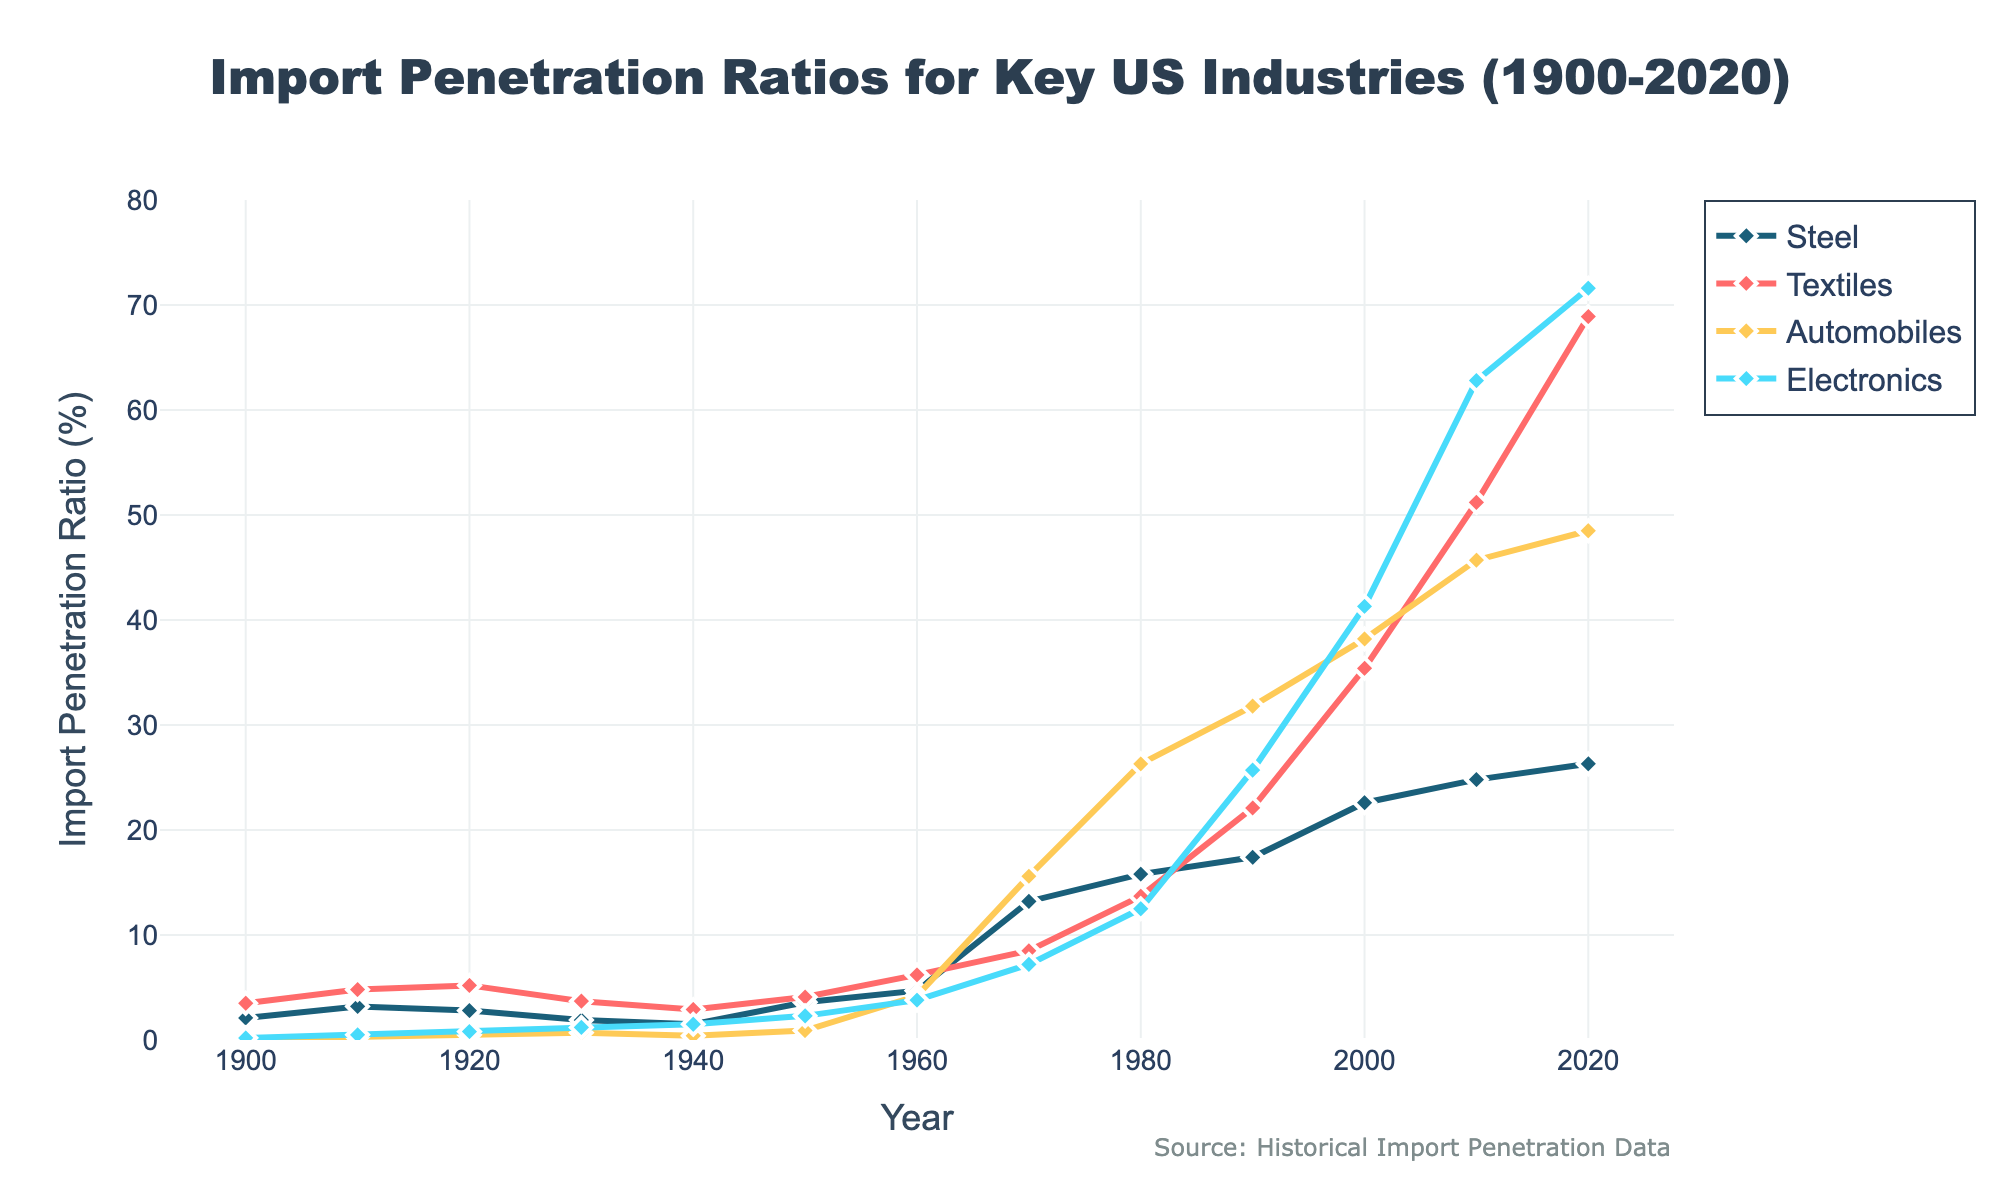what year did the import penetration ratio for Automobiles first exceed 30%? We look at the line representing Automobiles and see where it first crosses the 30% mark. This happens between 1980 (26.3%) and 1990 (31.8%). Hence, the year is 1990.
Answer: 1990 Between 1920 and 1940, which industry had the smallest change in import penetration ratio? Calculating the changes: Steel (2.8% to 1.5%, change of -1.3%), Textiles (5.2% to 2.9%, change of -2.3%), Automobiles (0.5% to 0.4%, change of -0.1%), Electronics (0.8% to 1.5%, change of +0.7%). Automobiles had the smallest change (-0.1%).
Answer: Automobiles By how much did the import penetration ratio for Textiles increase between 1970 and 2020? In 1970, Textiles had an import penetration ratio of 8.5%. In 2020, it was 68.9%. The increase is 68.9% - 8.5% = 60.4%.
Answer: 60.4% Which industry had the highest import penetration ratio in 2010, and what was it? Looking at the figure for 2010, Electronics had the highest import penetration ratio at 62.8%.
Answer: Electronics, 62.8% What is the average import penetration ratio for Steel from 1900 to 2020? Summing up the values for Steel (2.1, 3.2, 2.8, 1.9, 1.5, 3.6, 4.7, 13.2, 15.8, 17.4, 22.6, 24.8, 26.3) and dividing by the number of values (13): (2.1 + 3.2 + 2.8 + 1.9 + 1.5 + 3.6 + 4.7 + 13.2 + 15.8 + 17.4 + 22.6 + 24.8 + 26.3) / 13 = 12.3%.
Answer: 12.3% In which decade did Electronics see the most significant increase in import penetration ratio? Looking at the changes per decade: between 1960 (3.8%) and 1970 (7.2%) is an increase of 3.4%, 1970 (7.2%) and 1980 (12.5%) increase of 5.3%, 1980 (12.5%) and 1990 (25.7%) increase of 13.2%, 1990 (25.7%) and 2000 (41.3%) increase of 15.6%, 2000 (41.3%) and 2010 (62.8%) increase of 21.5%, and 2010 (62.8%) and 2020 (71.6%) increase of 8.8%. The most significant increase was between 2000 and 2010.
Answer: 2000-2010 Between 1900 and 2020, which two industries had their import penetration ratios cross and in which decade did this happen? We look at the lines representing the industries over the years. Steel and Textiles crossed in the 1950s. Automobiles and Electronics crossed in the 1970s. Textiles and Electronics crossed in the 1980s. The answer is Automobiles and Textiles in the 1970s.
Answer: Automobiles and Textiles, 1970s 